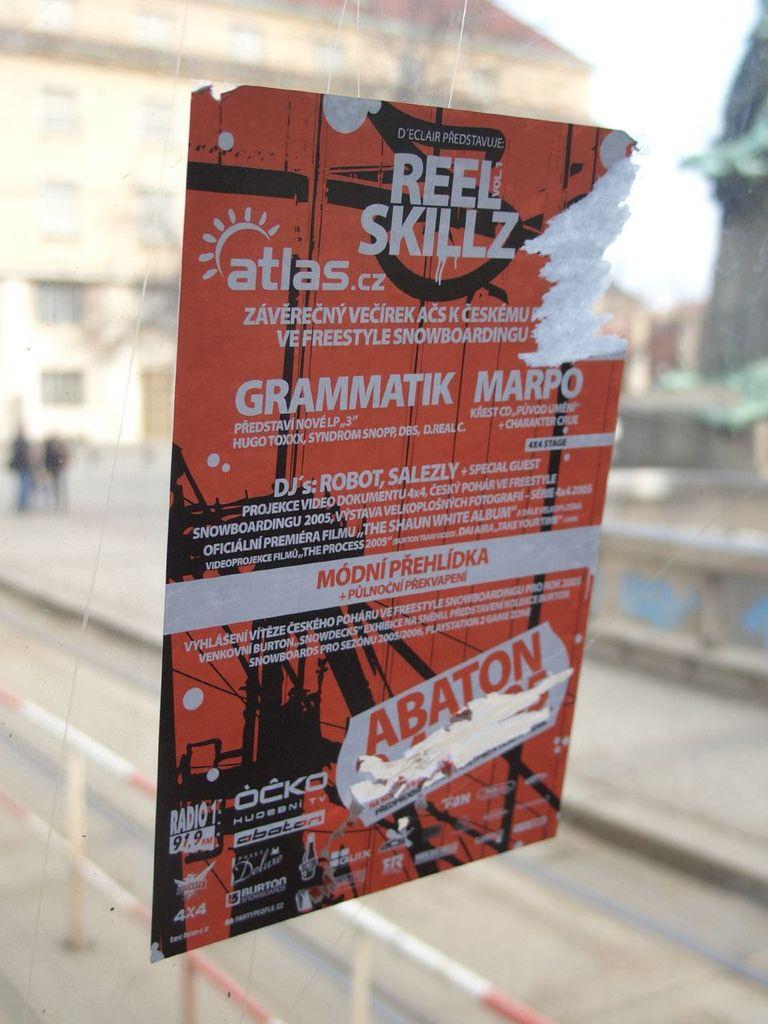Is radio 1 an am or fm station?
Give a very brief answer. Fm. What is the website domain extension for atlas?
Your answer should be very brief. .cz. 